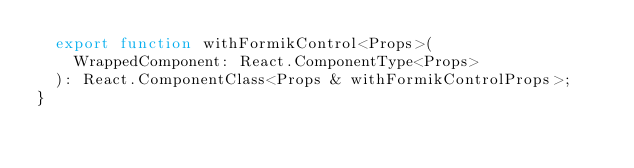<code> <loc_0><loc_0><loc_500><loc_500><_TypeScript_>  export function withFormikControl<Props>(
    WrappedComponent: React.ComponentType<Props>
  ): React.ComponentClass<Props & withFormikControlProps>;
}
</code> 